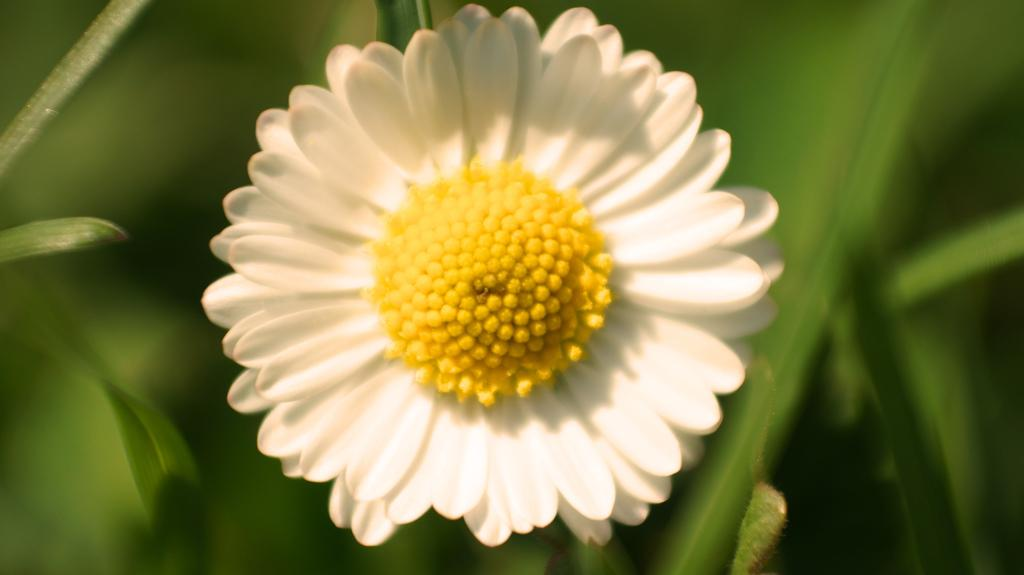What is the main subject of the picture? There is a flower in the picture. How would you describe the background of the image? The background of the image is blurred. What type of environment can be seen in the background? There is greenery visible in the background. What type of box can be seen holding the flower in the image? There is no box present in the image; the flower is not contained within a box. What rules are being followed by the flower in the image? There are no rules being followed by the flower in the image, as it is a static object in a photograph. 